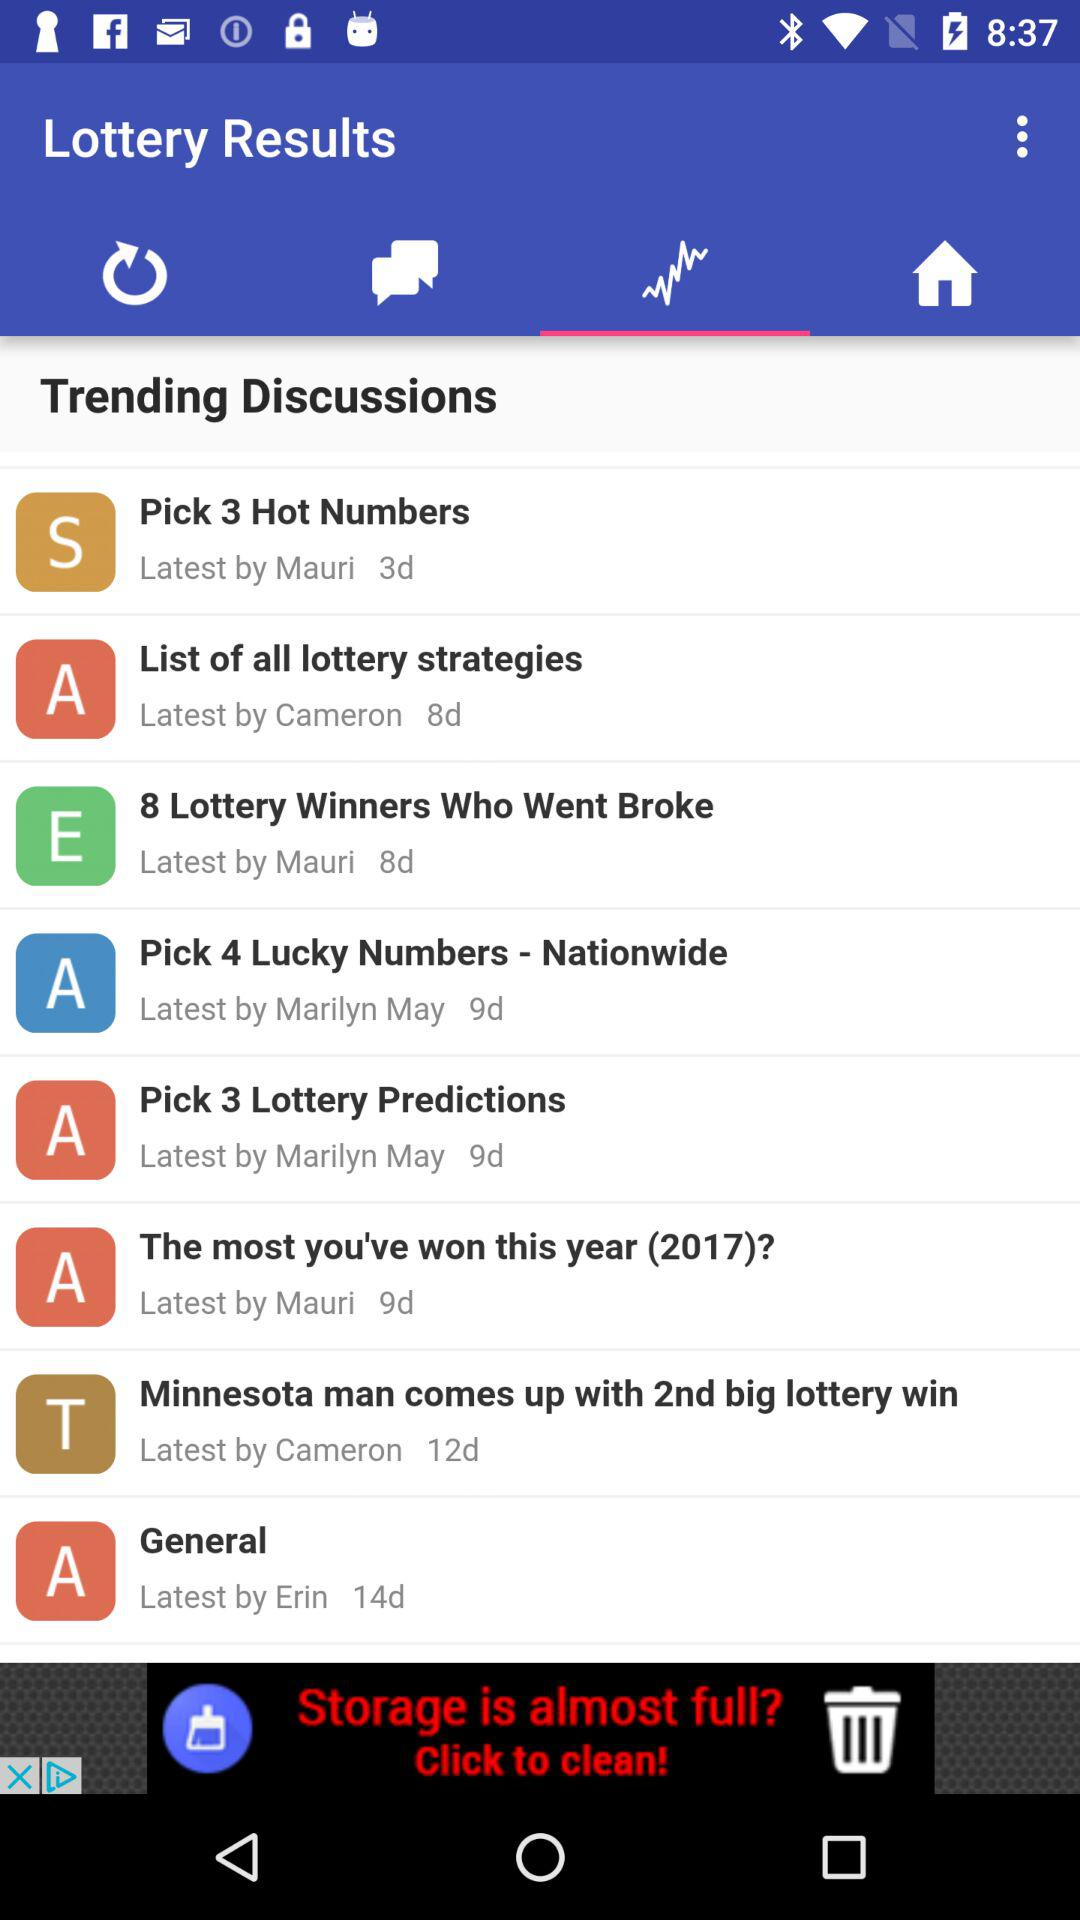Which trending discussions were done 3 days ago? The trending discussion "Pick 3 Hot Numbers" was done 3 days ago. 